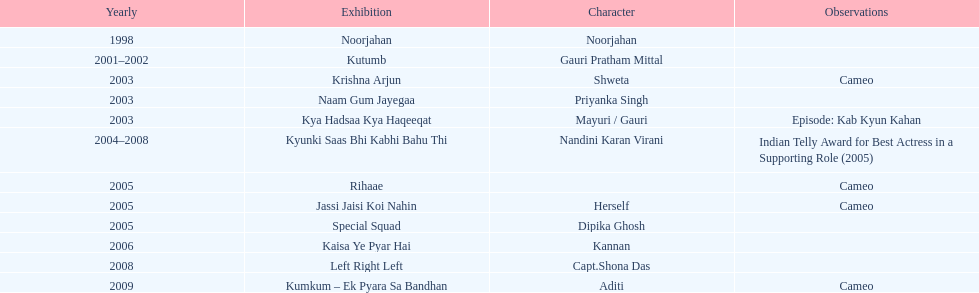Besides rihaae, in what other show did gauri tejwani cameo in 2005? Jassi Jaisi Koi Nahin. 